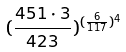<formula> <loc_0><loc_0><loc_500><loc_500>( \frac { 4 5 1 \cdot 3 } { 4 2 3 } ) ^ { ( \frac { 6 } { 1 1 7 } ) ^ { 4 } }</formula> 